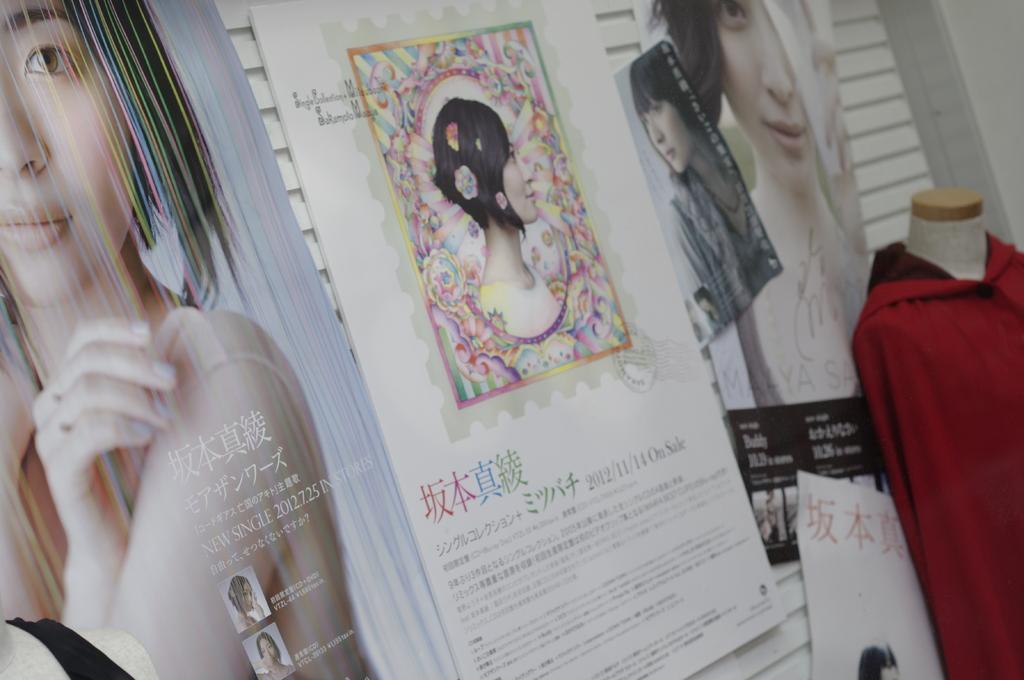Could you give a brief overview of what you see in this image? In this image we can see dress to the mannequin and advertisement boards to the walls. 